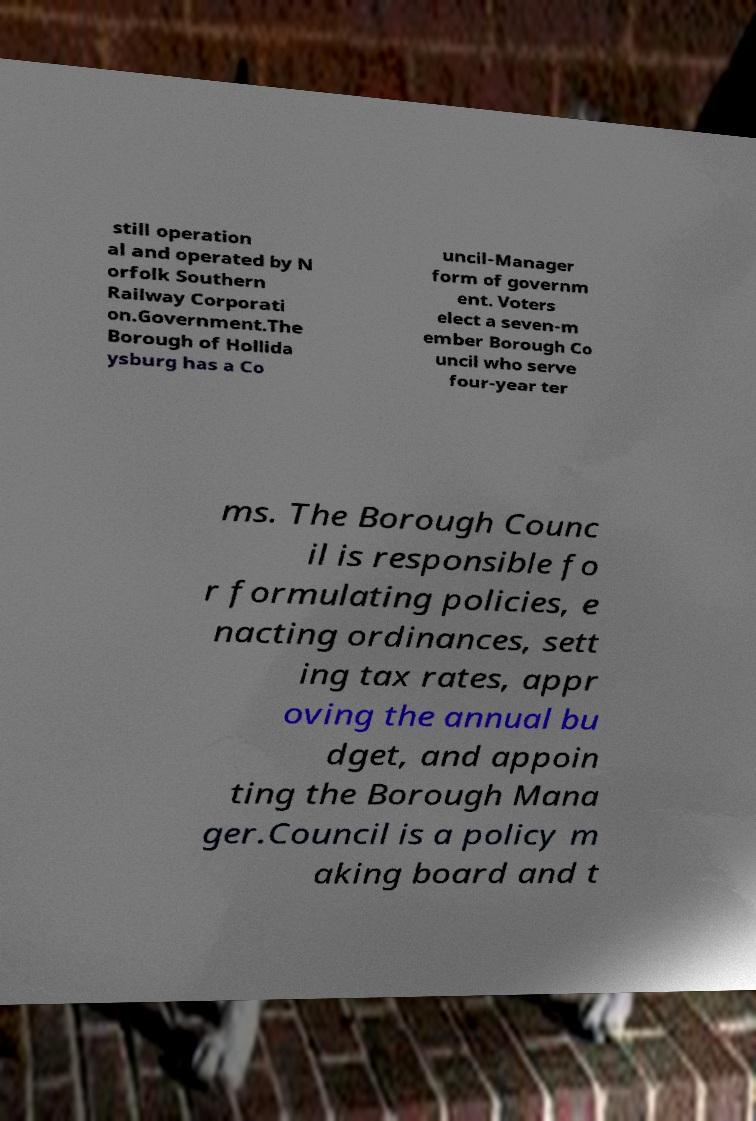There's text embedded in this image that I need extracted. Can you transcribe it verbatim? still operation al and operated by N orfolk Southern Railway Corporati on.Government.The Borough of Hollida ysburg has a Co uncil-Manager form of governm ent. Voters elect a seven-m ember Borough Co uncil who serve four-year ter ms. The Borough Counc il is responsible fo r formulating policies, e nacting ordinances, sett ing tax rates, appr oving the annual bu dget, and appoin ting the Borough Mana ger.Council is a policy m aking board and t 